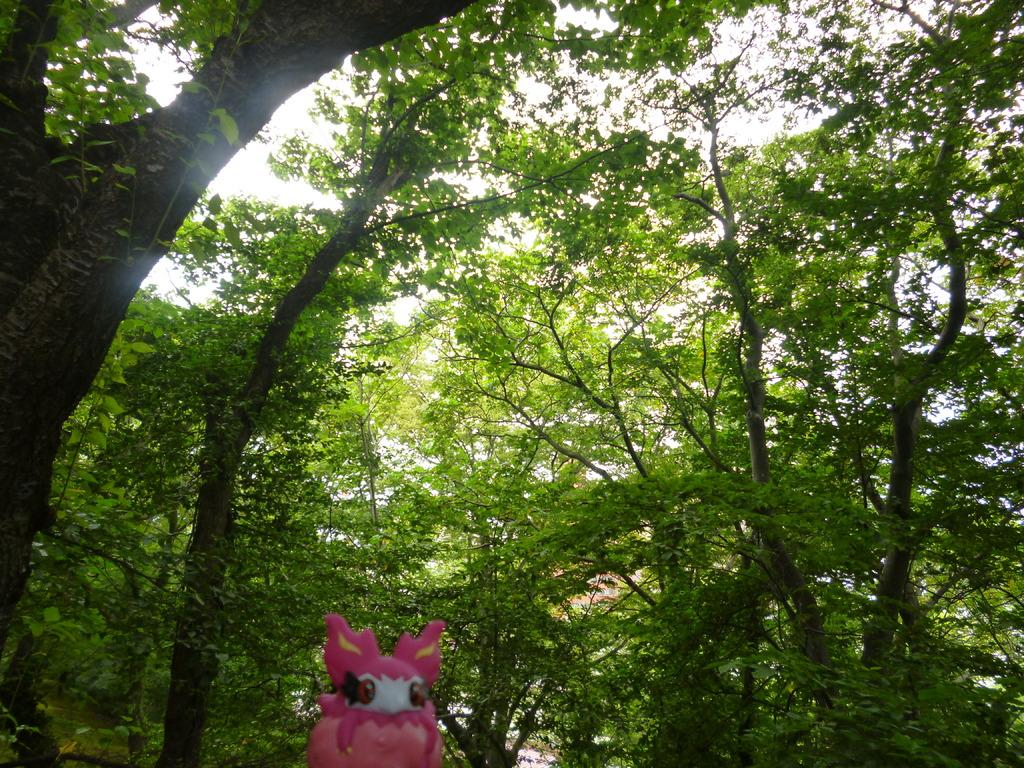What is the primary feature of the image? The primary feature of the image is the presence of many trees. Can you describe any specific objects in the image? Yes, there is a pink color toy at the bottom of the image. What type of organization is depicted in the image? There is no organization depicted in the image; it primarily features trees and a pink color toy. How does the society in the image contribute to the overall theme? There is no society present in the image, as it only contains trees and a pink color toy. 